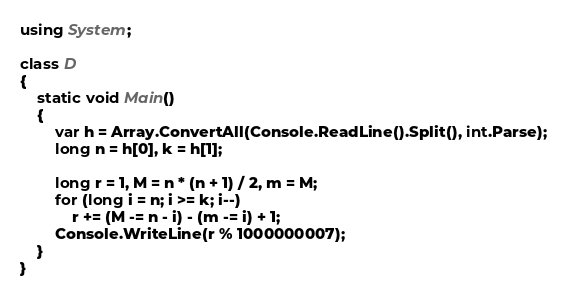<code> <loc_0><loc_0><loc_500><loc_500><_C#_>using System;

class D
{
	static void Main()
	{
		var h = Array.ConvertAll(Console.ReadLine().Split(), int.Parse);
		long n = h[0], k = h[1];

		long r = 1, M = n * (n + 1) / 2, m = M;
		for (long i = n; i >= k; i--)
			r += (M -= n - i) - (m -= i) + 1;
		Console.WriteLine(r % 1000000007);
	}
}
</code> 